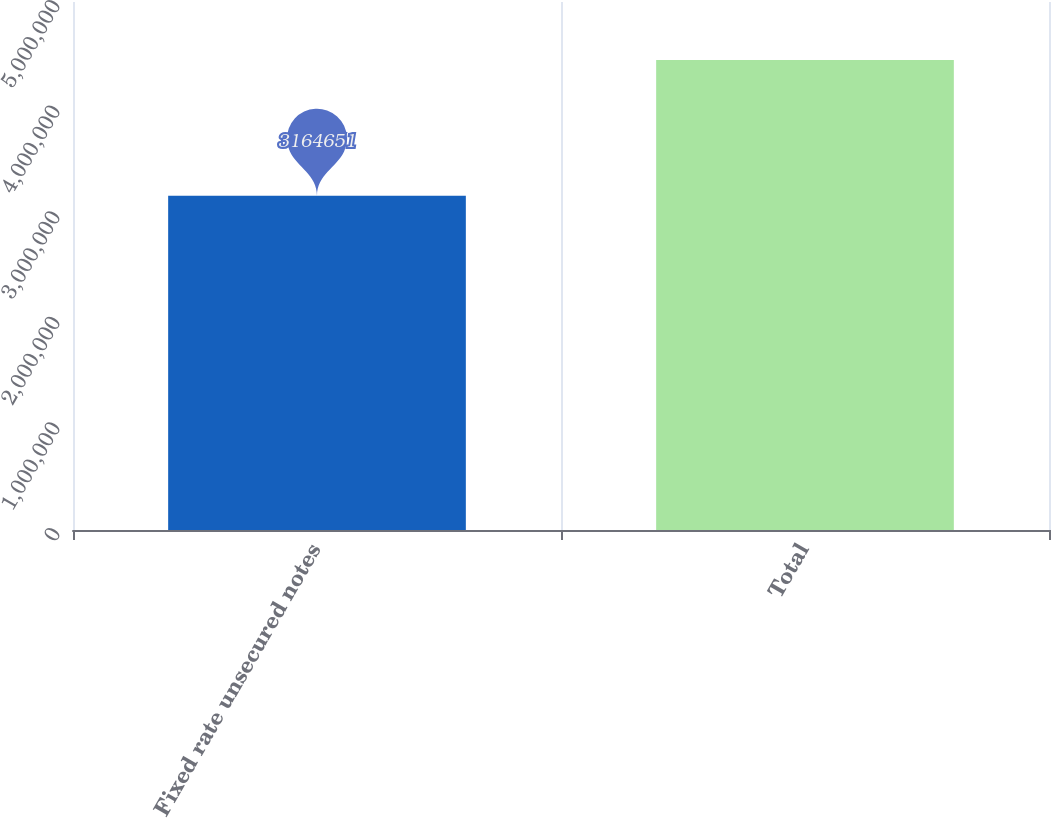<chart> <loc_0><loc_0><loc_500><loc_500><bar_chart><fcel>Fixed rate unsecured notes<fcel>Total<nl><fcel>3.16465e+06<fcel>4.45034e+06<nl></chart> 